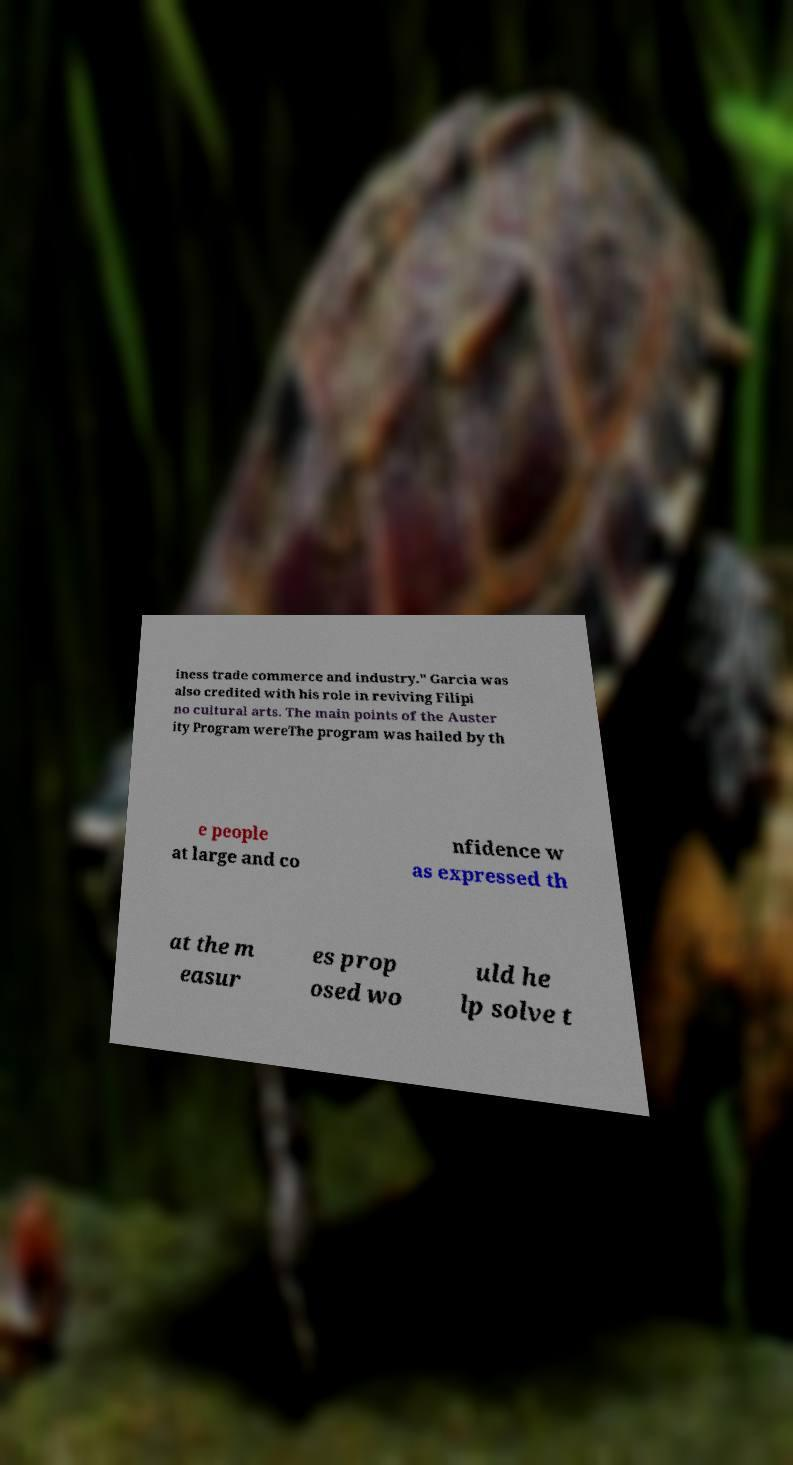Could you assist in decoding the text presented in this image and type it out clearly? iness trade commerce and industry." Garcia was also credited with his role in reviving Filipi no cultural arts. The main points of the Auster ity Program wereThe program was hailed by th e people at large and co nfidence w as expressed th at the m easur es prop osed wo uld he lp solve t 